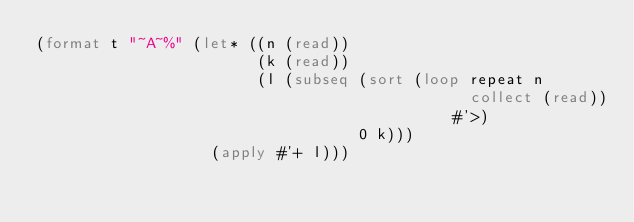<code> <loc_0><loc_0><loc_500><loc_500><_Lisp_>(format t "~A~%" (let* ((n (read))
                        (k (read))
                        (l (subseq (sort (loop repeat n
                                               collect (read))
                                             #'>)
                                   0 k)))
                   (apply #'+ l)))</code> 